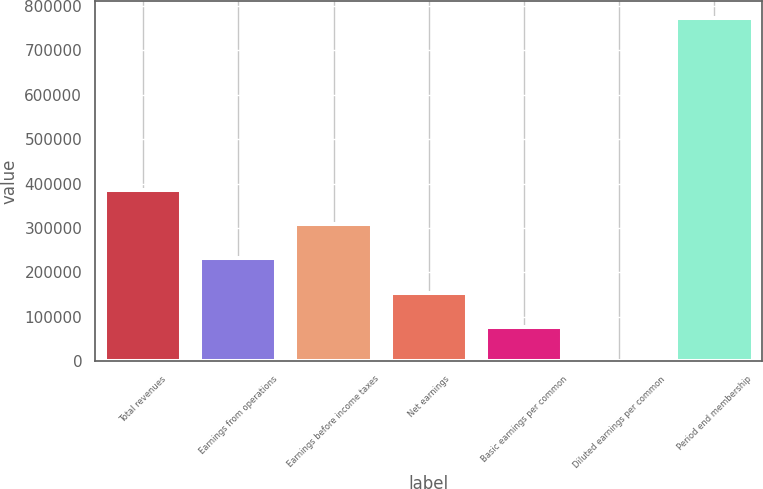<chart> <loc_0><loc_0><loc_500><loc_500><bar_chart><fcel>Total revenues<fcel>Earnings from operations<fcel>Earnings before income taxes<fcel>Net earnings<fcel>Basic earnings per common<fcel>Diluted earnings per common<fcel>Period end membership<nl><fcel>386350<fcel>231810<fcel>309080<fcel>154540<fcel>77270.2<fcel>0.27<fcel>772700<nl></chart> 